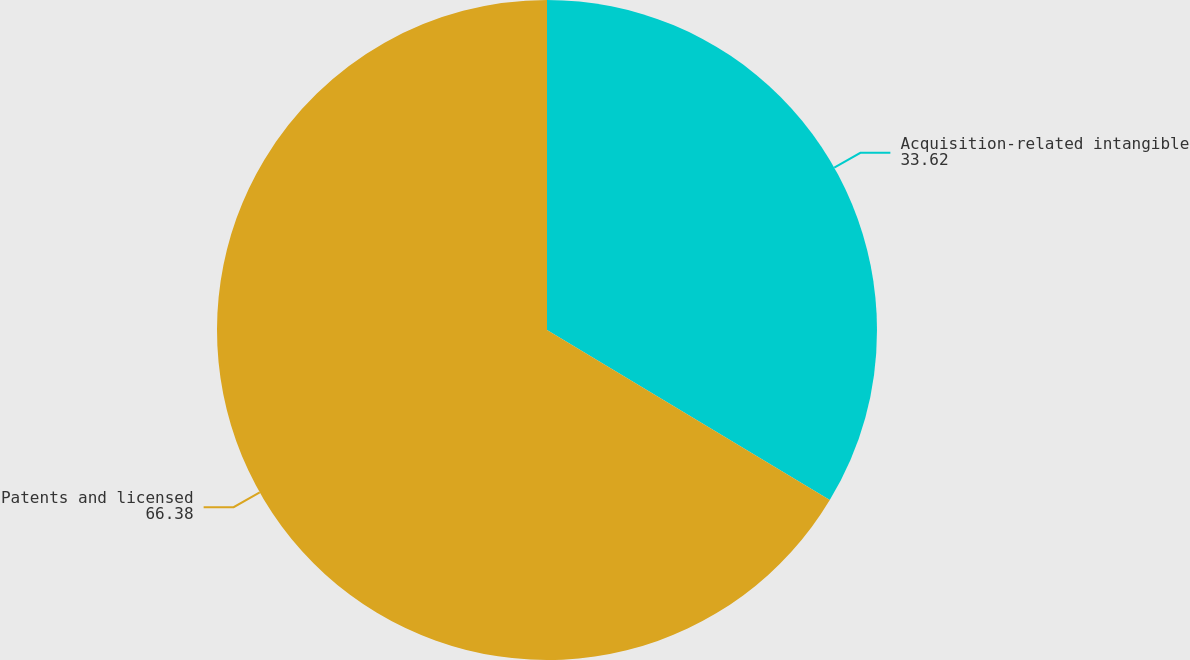Convert chart to OTSL. <chart><loc_0><loc_0><loc_500><loc_500><pie_chart><fcel>Acquisition-related intangible<fcel>Patents and licensed<nl><fcel>33.62%<fcel>66.38%<nl></chart> 